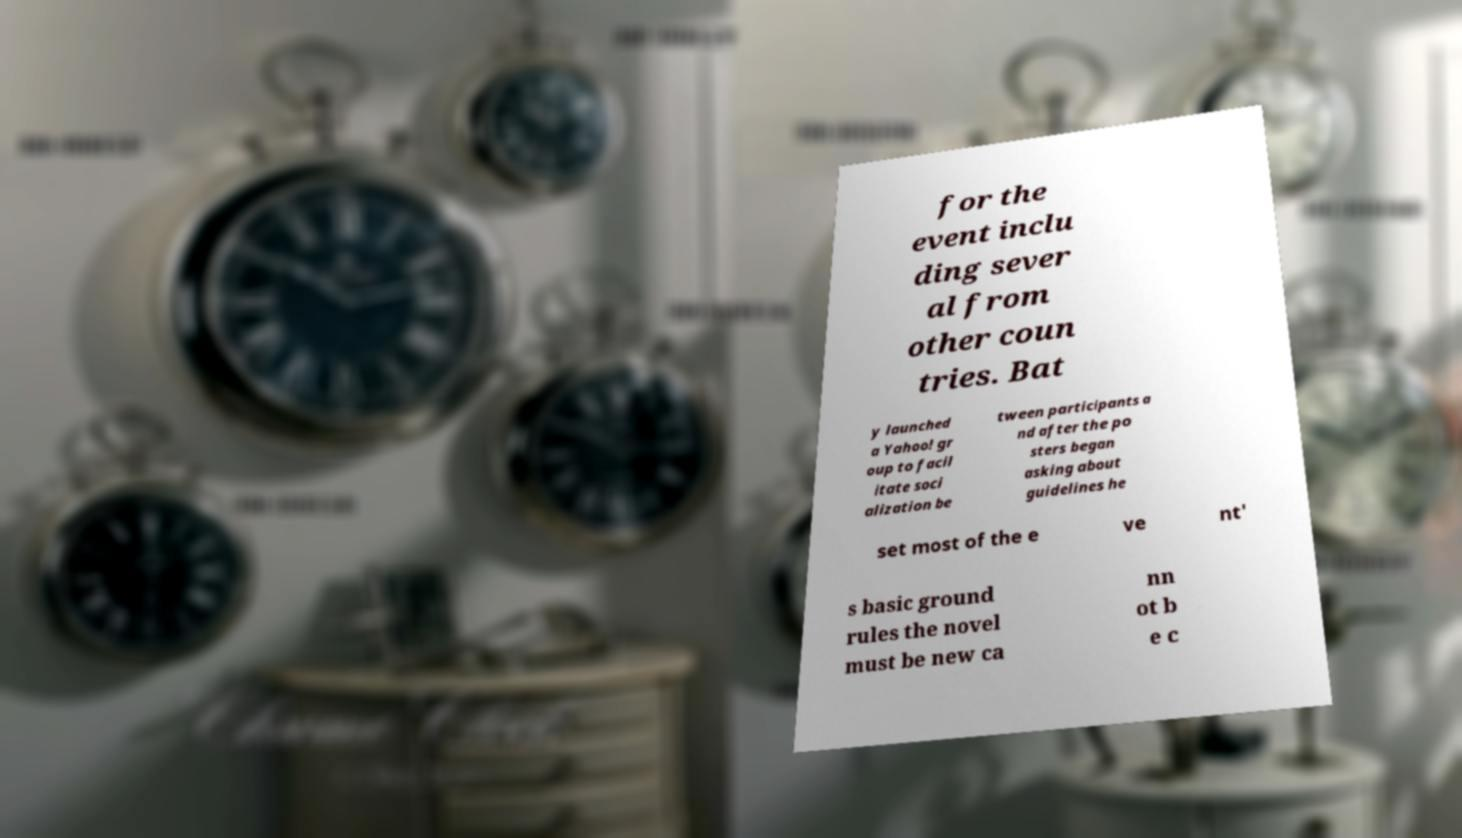I need the written content from this picture converted into text. Can you do that? for the event inclu ding sever al from other coun tries. Bat y launched a Yahoo! gr oup to facil itate soci alization be tween participants a nd after the po sters began asking about guidelines he set most of the e ve nt' s basic ground rules the novel must be new ca nn ot b e c 